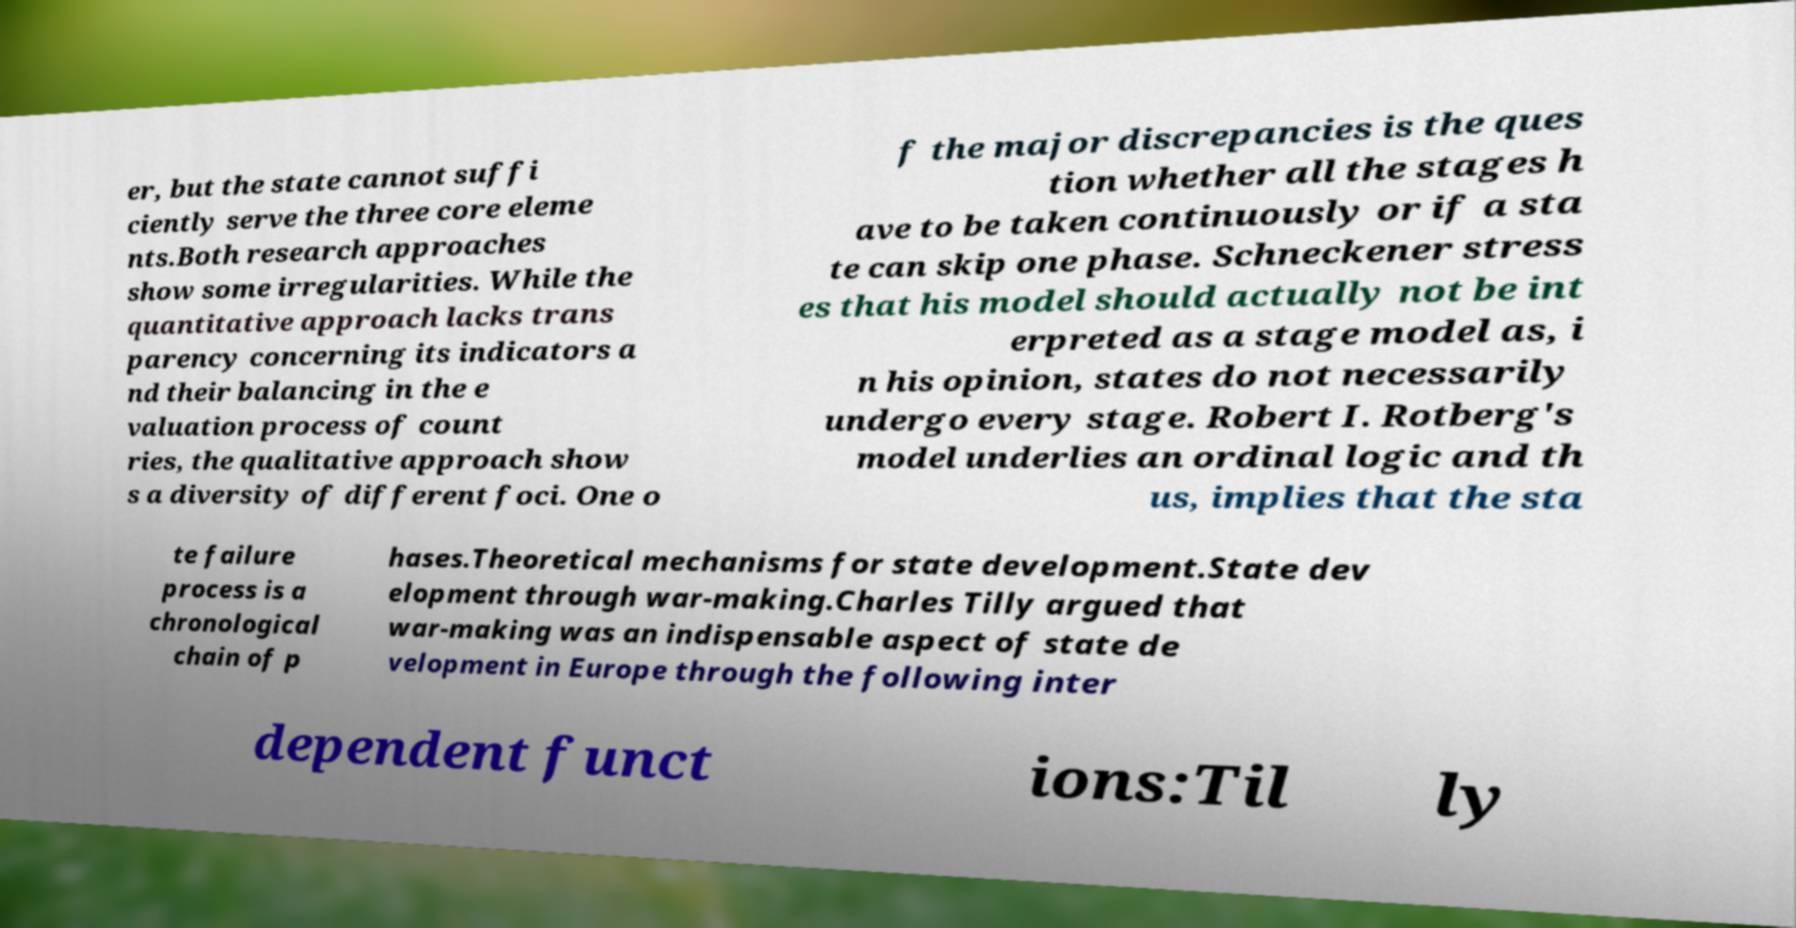Please read and relay the text visible in this image. What does it say? er, but the state cannot suffi ciently serve the three core eleme nts.Both research approaches show some irregularities. While the quantitative approach lacks trans parency concerning its indicators a nd their balancing in the e valuation process of count ries, the qualitative approach show s a diversity of different foci. One o f the major discrepancies is the ques tion whether all the stages h ave to be taken continuously or if a sta te can skip one phase. Schneckener stress es that his model should actually not be int erpreted as a stage model as, i n his opinion, states do not necessarily undergo every stage. Robert I. Rotberg's model underlies an ordinal logic and th us, implies that the sta te failure process is a chronological chain of p hases.Theoretical mechanisms for state development.State dev elopment through war-making.Charles Tilly argued that war-making was an indispensable aspect of state de velopment in Europe through the following inter dependent funct ions:Til ly 